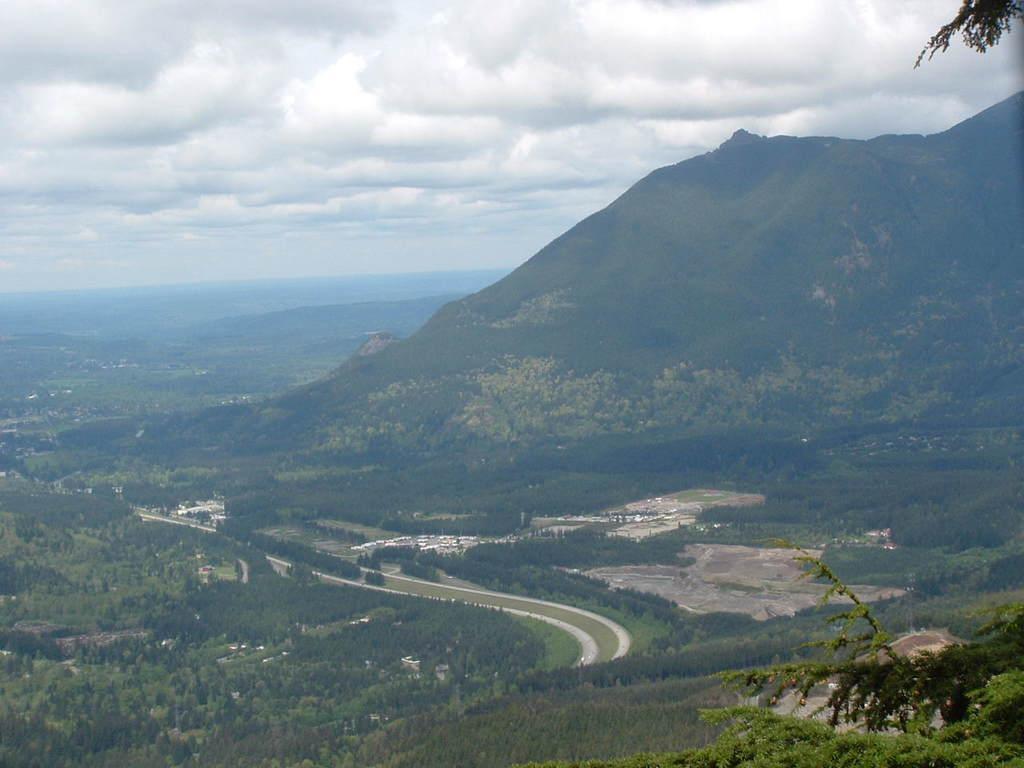Can you describe this image briefly? In this image I can see trees, plants, hills and in the background there is sky. 